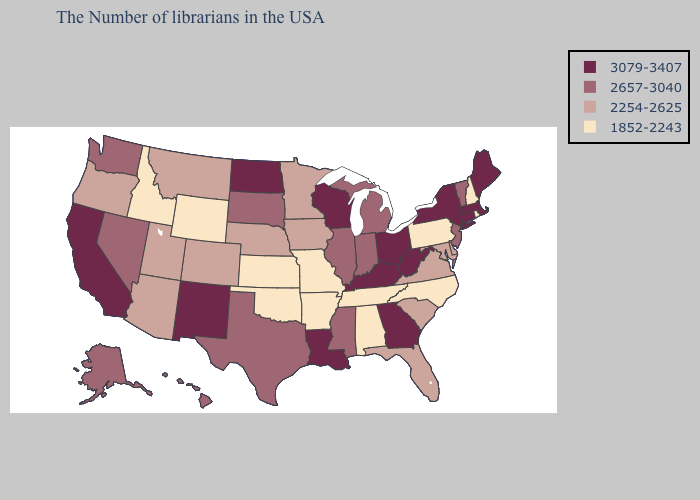Is the legend a continuous bar?
Concise answer only. No. Does Indiana have the same value as Oregon?
Quick response, please. No. What is the value of Kentucky?
Quick response, please. 3079-3407. Name the states that have a value in the range 1852-2243?
Quick response, please. Rhode Island, New Hampshire, Pennsylvania, North Carolina, Alabama, Tennessee, Missouri, Arkansas, Kansas, Oklahoma, Wyoming, Idaho. Does the first symbol in the legend represent the smallest category?
Be succinct. No. Does Nevada have a higher value than North Dakota?
Be succinct. No. Does New York have the highest value in the USA?
Write a very short answer. Yes. What is the value of Delaware?
Keep it brief. 2254-2625. Among the states that border Michigan , does Indiana have the highest value?
Write a very short answer. No. Does Utah have the same value as Virginia?
Write a very short answer. Yes. Name the states that have a value in the range 2254-2625?
Short answer required. Delaware, Maryland, Virginia, South Carolina, Florida, Minnesota, Iowa, Nebraska, Colorado, Utah, Montana, Arizona, Oregon. Which states hav the highest value in the South?
Answer briefly. West Virginia, Georgia, Kentucky, Louisiana. Which states have the highest value in the USA?
Be succinct. Maine, Massachusetts, Connecticut, New York, West Virginia, Ohio, Georgia, Kentucky, Wisconsin, Louisiana, North Dakota, New Mexico, California. What is the highest value in the South ?
Concise answer only. 3079-3407. What is the highest value in the USA?
Short answer required. 3079-3407. 